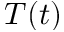<formula> <loc_0><loc_0><loc_500><loc_500>T ( t )</formula> 